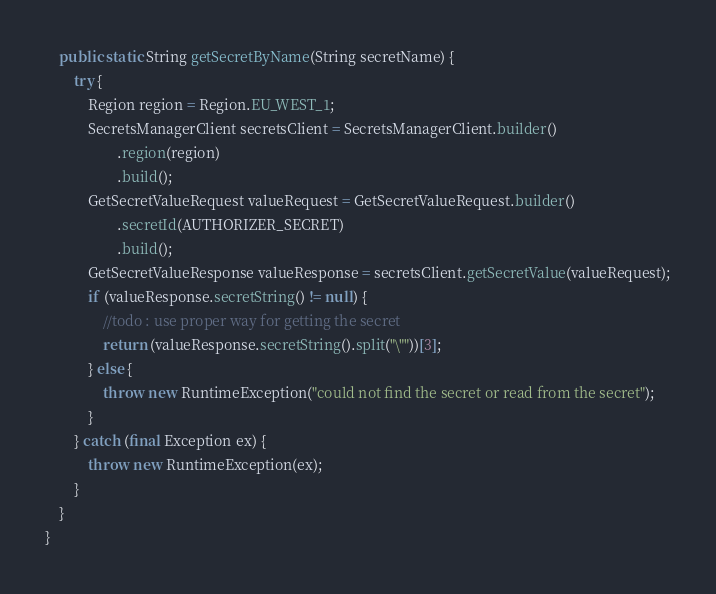<code> <loc_0><loc_0><loc_500><loc_500><_Java_>    public static String getSecretByName(String secretName) {
        try {
            Region region = Region.EU_WEST_1;
            SecretsManagerClient secretsClient = SecretsManagerClient.builder()
                    .region(region)
                    .build();
            GetSecretValueRequest valueRequest = GetSecretValueRequest.builder()
                    .secretId(AUTHORIZER_SECRET)
                    .build();
            GetSecretValueResponse valueResponse = secretsClient.getSecretValue(valueRequest);
            if (valueResponse.secretString() != null) {
                //todo : use proper way for getting the secret
                return (valueResponse.secretString().split("\""))[3];
            } else {
                throw new RuntimeException("could not find the secret or read from the secret");
            }
        } catch (final Exception ex) {
            throw new RuntimeException(ex);
        }
    }
}
</code> 